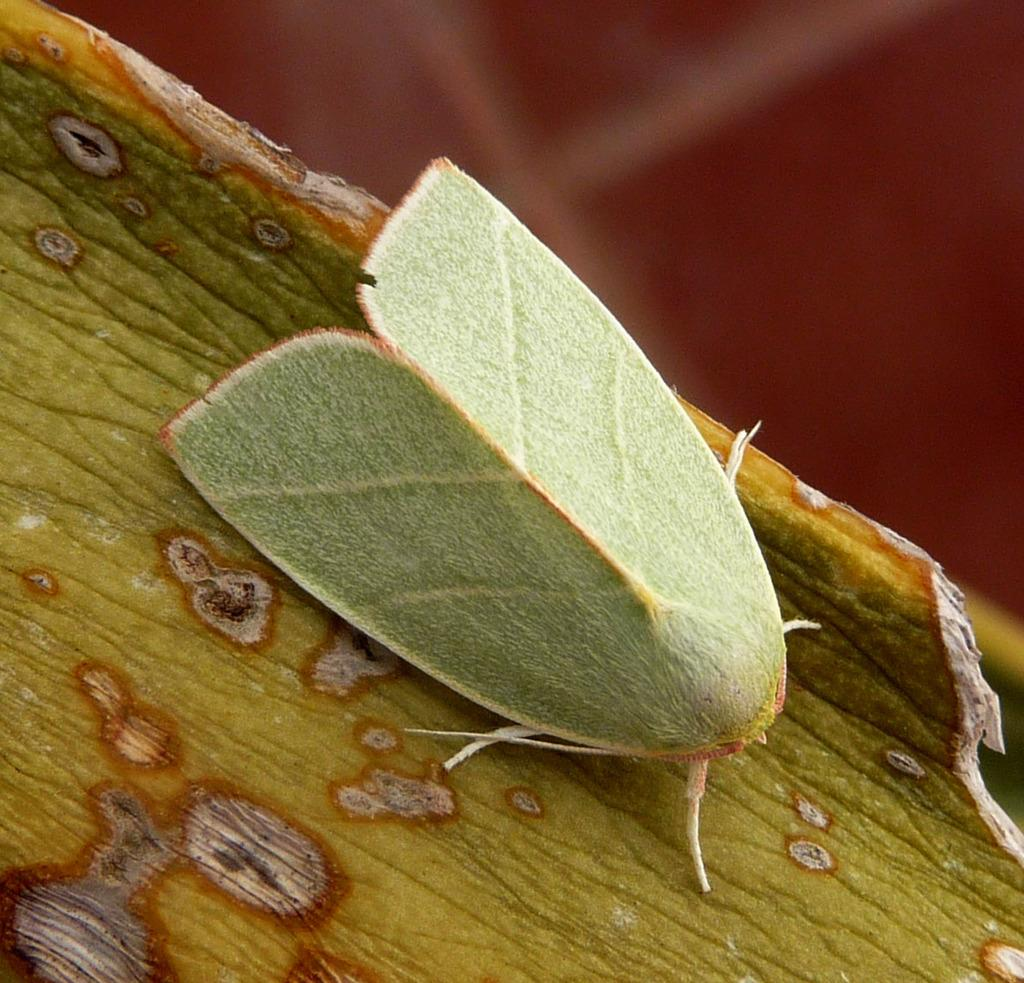What type of creature can be seen in the image? There is an insect in the image. What is the insect sitting on? The insect is on a wooden object. Can you describe the background of the image? The background of the image is blurry. What book is the insect reading in the image? There is no book present in the image, and insects do not read books. 